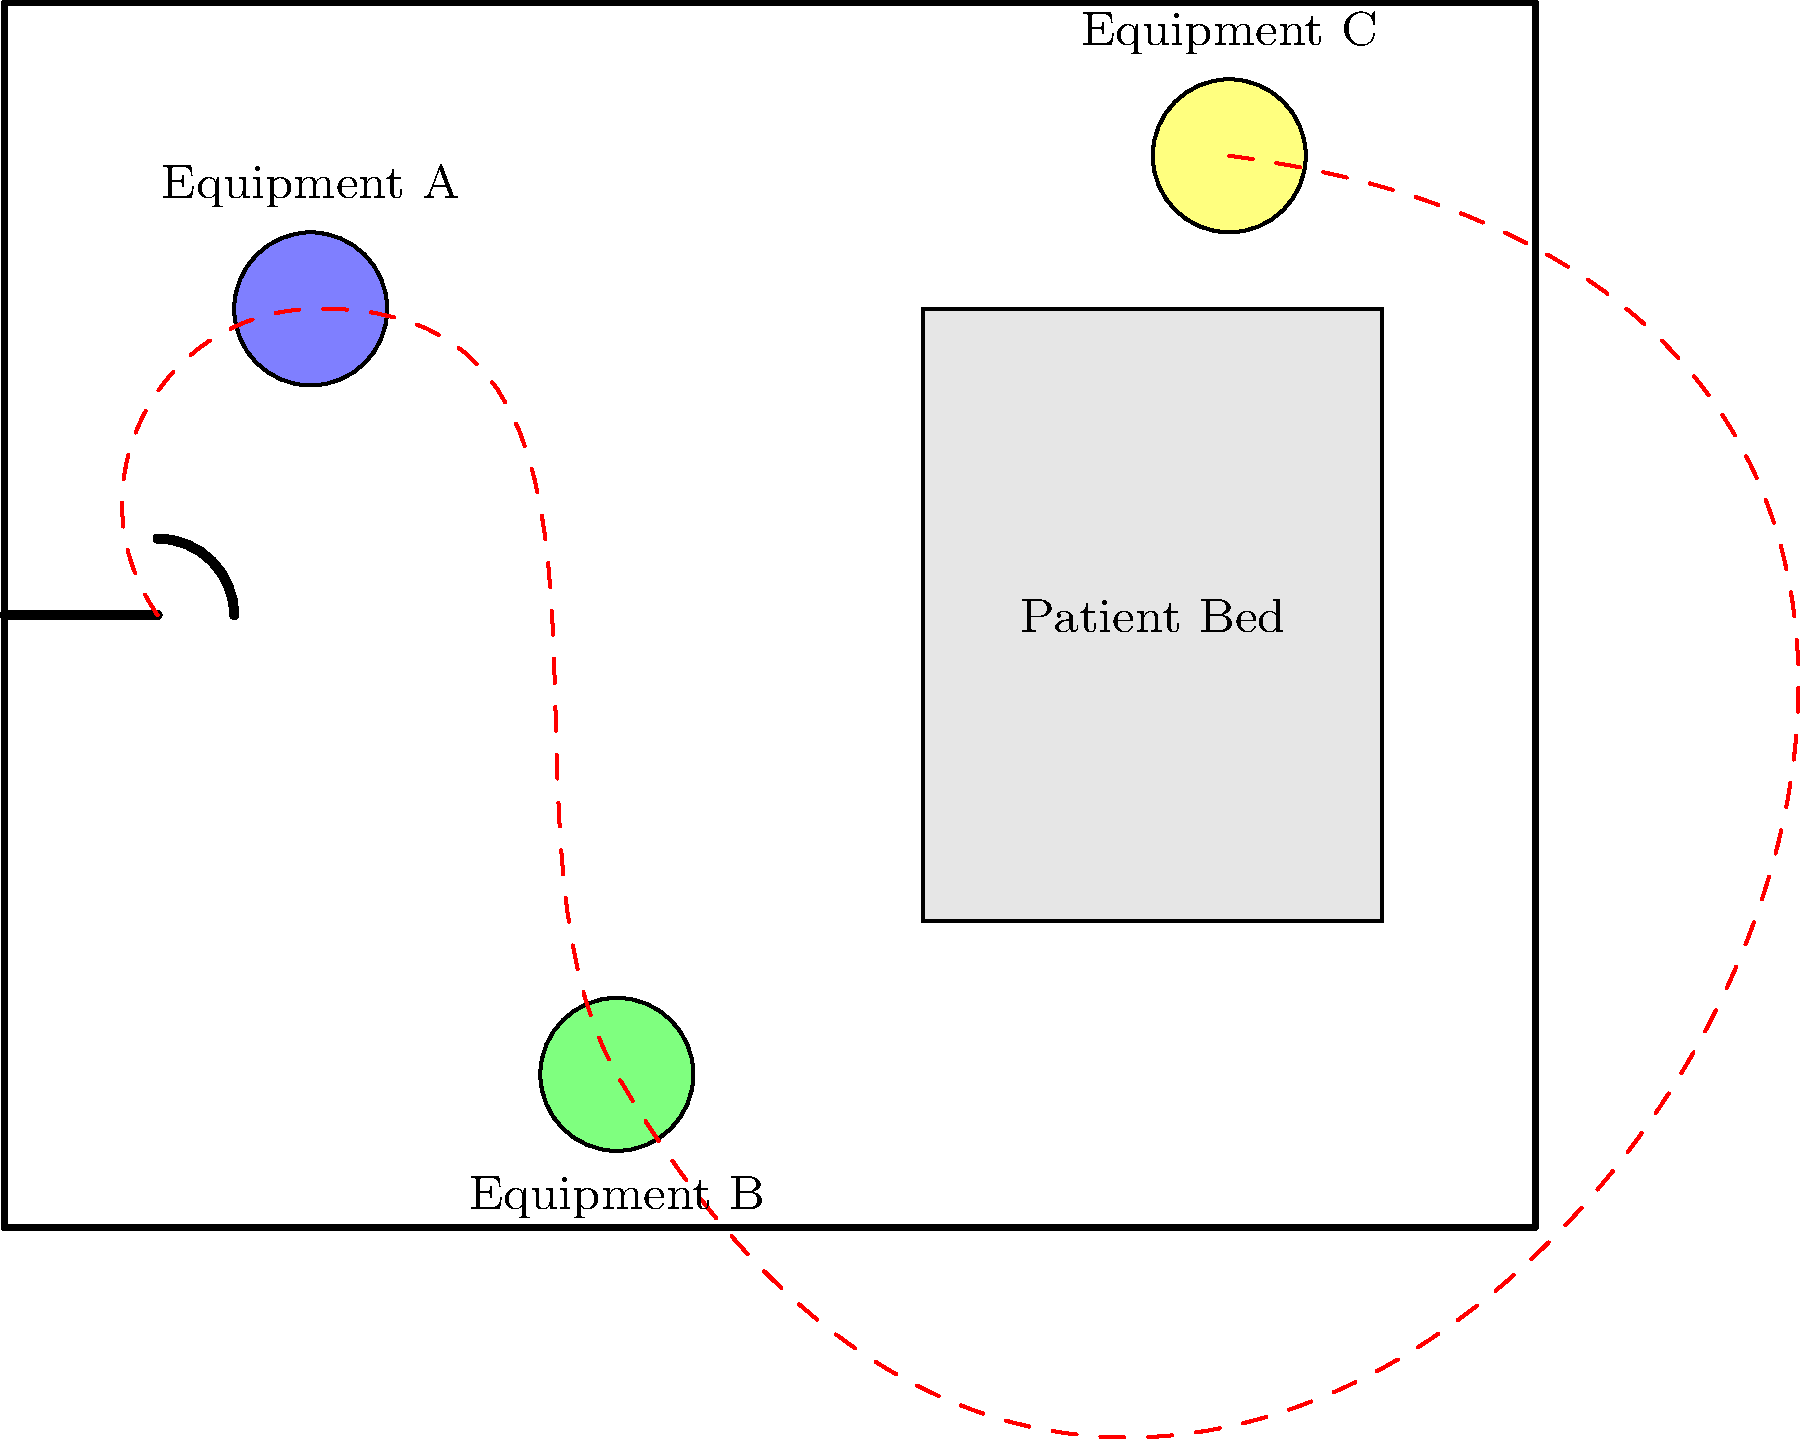In the given top-down layout of a patient room, three pieces of medical equipment (A, B, and C) are placed at different locations. Considering ergonomic principles and the nurse's movement path, which equipment placement is most problematic and should be relocated to improve efficiency and reduce physical strain on the nursing staff? To determine which equipment placement is most problematic, we need to consider several ergonomic factors:

1. Frequency of use: Equipment used more frequently should be closer to the patient and easily accessible.

2. Distance from the patient: Equipment should be within reach of the patient when necessary.

3. Nurse's movement path: The layout should minimize the distance traveled by the nurse and avoid obstacles.

4. Potential for strain: Equipment placement should reduce bending, stretching, or awkward postures.

Analyzing each equipment placement:

A. Equipment A is close to the door and on the nurse's path. It's relatively accessible but might obstruct entry to the room.

B. Equipment B is far from the patient bed and requires the nurse to bend down to access it, potentially causing back strain.

C. Equipment C is close to the patient bed but in the corner, which may require reaching across the bed to access it.

Considering these factors:

- Equipment B is the most problematic because:
  1. It's the farthest from the patient bed.
  2. It requires the nurse to travel the longest distance.
  3. Its low position may cause repeated bending and potential back strain.
  4. It's not on a direct path between the door and the patient bed.

Relocating Equipment B closer to the patient bed and at a more ergonomic height would significantly improve the room's layout, reducing physical strain on the nursing staff and improving efficiency.
Answer: Equipment B 